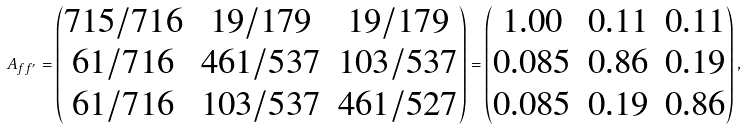Convert formula to latex. <formula><loc_0><loc_0><loc_500><loc_500>A _ { f f ^ { \prime } } = \begin{pmatrix} 7 1 5 / 7 1 6 & 1 9 / 1 7 9 & 1 9 / 1 7 9 \\ 6 1 / 7 1 6 & 4 6 1 / 5 3 7 & 1 0 3 / 5 3 7 \\ 6 1 / 7 1 6 & 1 0 3 / 5 3 7 & 4 6 1 / 5 2 7 \end{pmatrix} = \begin{pmatrix} 1 . 0 0 & 0 . 1 1 & 0 . 1 1 \\ 0 . 0 8 5 & 0 . 8 6 & 0 . 1 9 \\ 0 . 0 8 5 & 0 . 1 9 & 0 . 8 6 \end{pmatrix} ,</formula> 